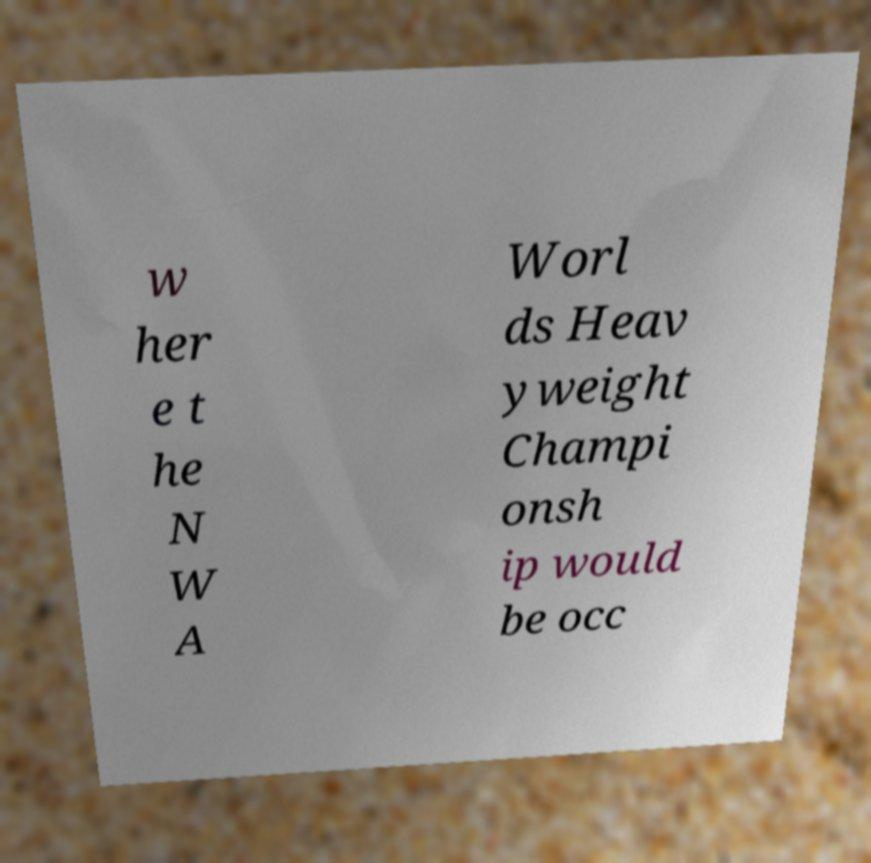There's text embedded in this image that I need extracted. Can you transcribe it verbatim? w her e t he N W A Worl ds Heav yweight Champi onsh ip would be occ 